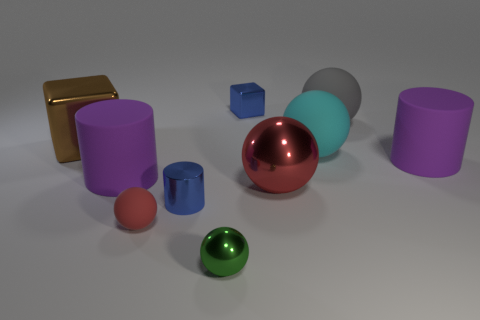Is there any other thing that has the same color as the small shiny cylinder?
Ensure brevity in your answer.  Yes. Are there fewer purple matte objects that are behind the gray object than small purple matte spheres?
Your response must be concise. No. Are there more purple cylinders than tiny metal blocks?
Offer a terse response. Yes. Are there any blocks behind the gray matte ball that is behind the large purple thing right of the tiny block?
Your answer should be very brief. Yes. What number of other things are there of the same size as the red shiny sphere?
Your response must be concise. 5. Are there any matte cylinders on the left side of the green metallic sphere?
Your response must be concise. Yes. Do the tiny cube and the cylinder in front of the big red object have the same color?
Give a very brief answer. Yes. What color is the large metallic thing that is on the left side of the tiny thing that is behind the large shiny object left of the green object?
Offer a very short reply. Brown. Is there a large metallic thing of the same shape as the tiny matte object?
Ensure brevity in your answer.  Yes. What is the color of the matte sphere that is the same size as the blue metal cylinder?
Your response must be concise. Red. 